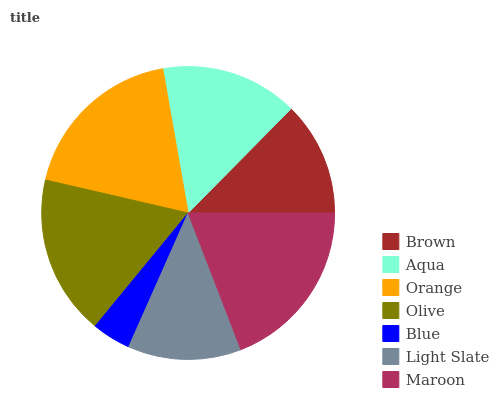Is Blue the minimum?
Answer yes or no. Yes. Is Maroon the maximum?
Answer yes or no. Yes. Is Aqua the minimum?
Answer yes or no. No. Is Aqua the maximum?
Answer yes or no. No. Is Aqua greater than Brown?
Answer yes or no. Yes. Is Brown less than Aqua?
Answer yes or no. Yes. Is Brown greater than Aqua?
Answer yes or no. No. Is Aqua less than Brown?
Answer yes or no. No. Is Aqua the high median?
Answer yes or no. Yes. Is Aqua the low median?
Answer yes or no. Yes. Is Light Slate the high median?
Answer yes or no. No. Is Olive the low median?
Answer yes or no. No. 